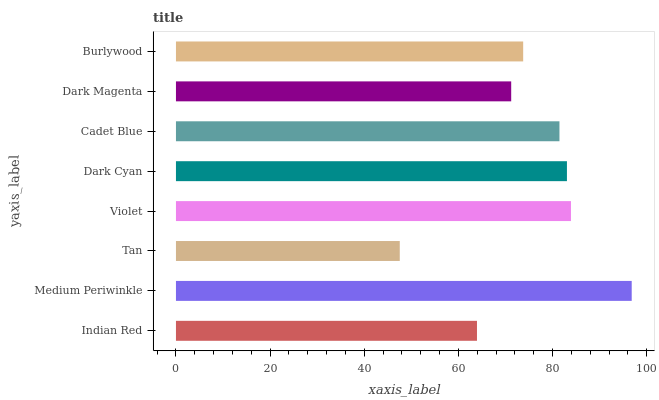Is Tan the minimum?
Answer yes or no. Yes. Is Medium Periwinkle the maximum?
Answer yes or no. Yes. Is Medium Periwinkle the minimum?
Answer yes or no. No. Is Tan the maximum?
Answer yes or no. No. Is Medium Periwinkle greater than Tan?
Answer yes or no. Yes. Is Tan less than Medium Periwinkle?
Answer yes or no. Yes. Is Tan greater than Medium Periwinkle?
Answer yes or no. No. Is Medium Periwinkle less than Tan?
Answer yes or no. No. Is Cadet Blue the high median?
Answer yes or no. Yes. Is Burlywood the low median?
Answer yes or no. Yes. Is Dark Magenta the high median?
Answer yes or no. No. Is Tan the low median?
Answer yes or no. No. 